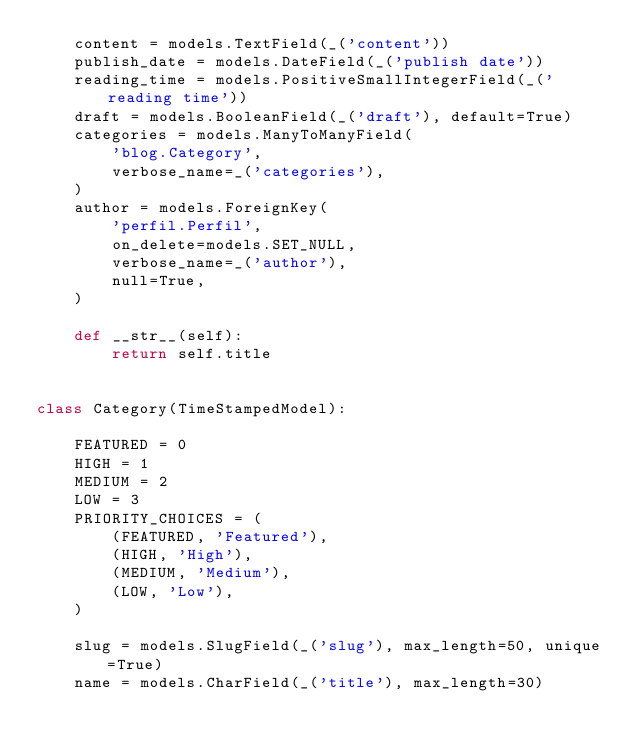<code> <loc_0><loc_0><loc_500><loc_500><_Python_>    content = models.TextField(_('content'))
    publish_date = models.DateField(_('publish date'))
    reading_time = models.PositiveSmallIntegerField(_('reading time'))
    draft = models.BooleanField(_('draft'), default=True)
    categories = models.ManyToManyField(
        'blog.Category',
        verbose_name=_('categories'),
    )
    author = models.ForeignKey(
        'perfil.Perfil',
        on_delete=models.SET_NULL,
        verbose_name=_('author'),
        null=True,
    )

    def __str__(self):
        return self.title


class Category(TimeStampedModel):

    FEATURED = 0
    HIGH = 1
    MEDIUM = 2
    LOW = 3
    PRIORITY_CHOICES = (
        (FEATURED, 'Featured'),
        (HIGH, 'High'),
        (MEDIUM, 'Medium'),
        (LOW, 'Low'),
    )

    slug = models.SlugField(_('slug'), max_length=50, unique=True)
    name = models.CharField(_('title'), max_length=30)</code> 